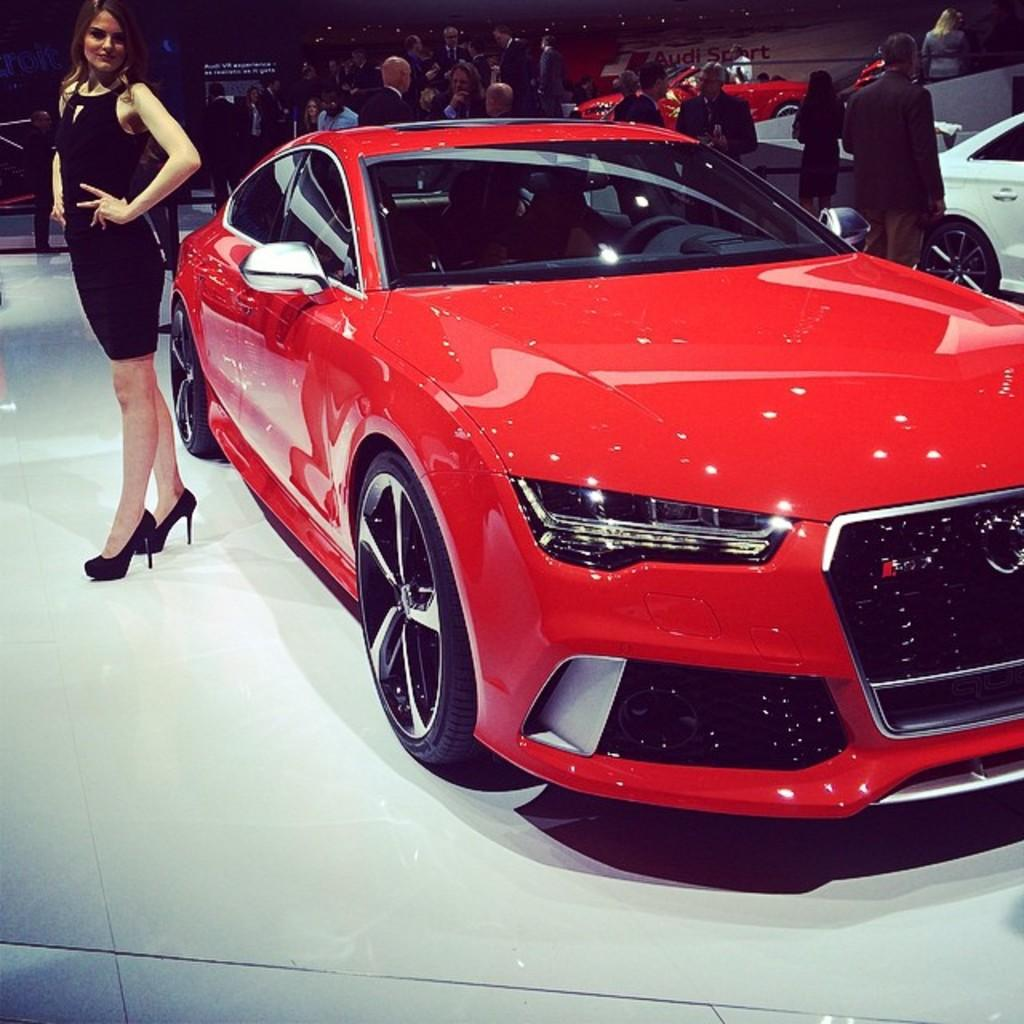What can be seen in the image involving people? There are people standing in the image. What type of objects are on the floor in the image? There are motor vehicles on the floor in the image. What can be seen in the background of the image? There are barrier poles and an advertisement board in the background of the image. Where is the playground located in the image? There is no playground present in the image. What type of trousers are the people wearing in the image? The provided facts do not mention the type of trousers the people are wearing, so we cannot determine that information from the image. 